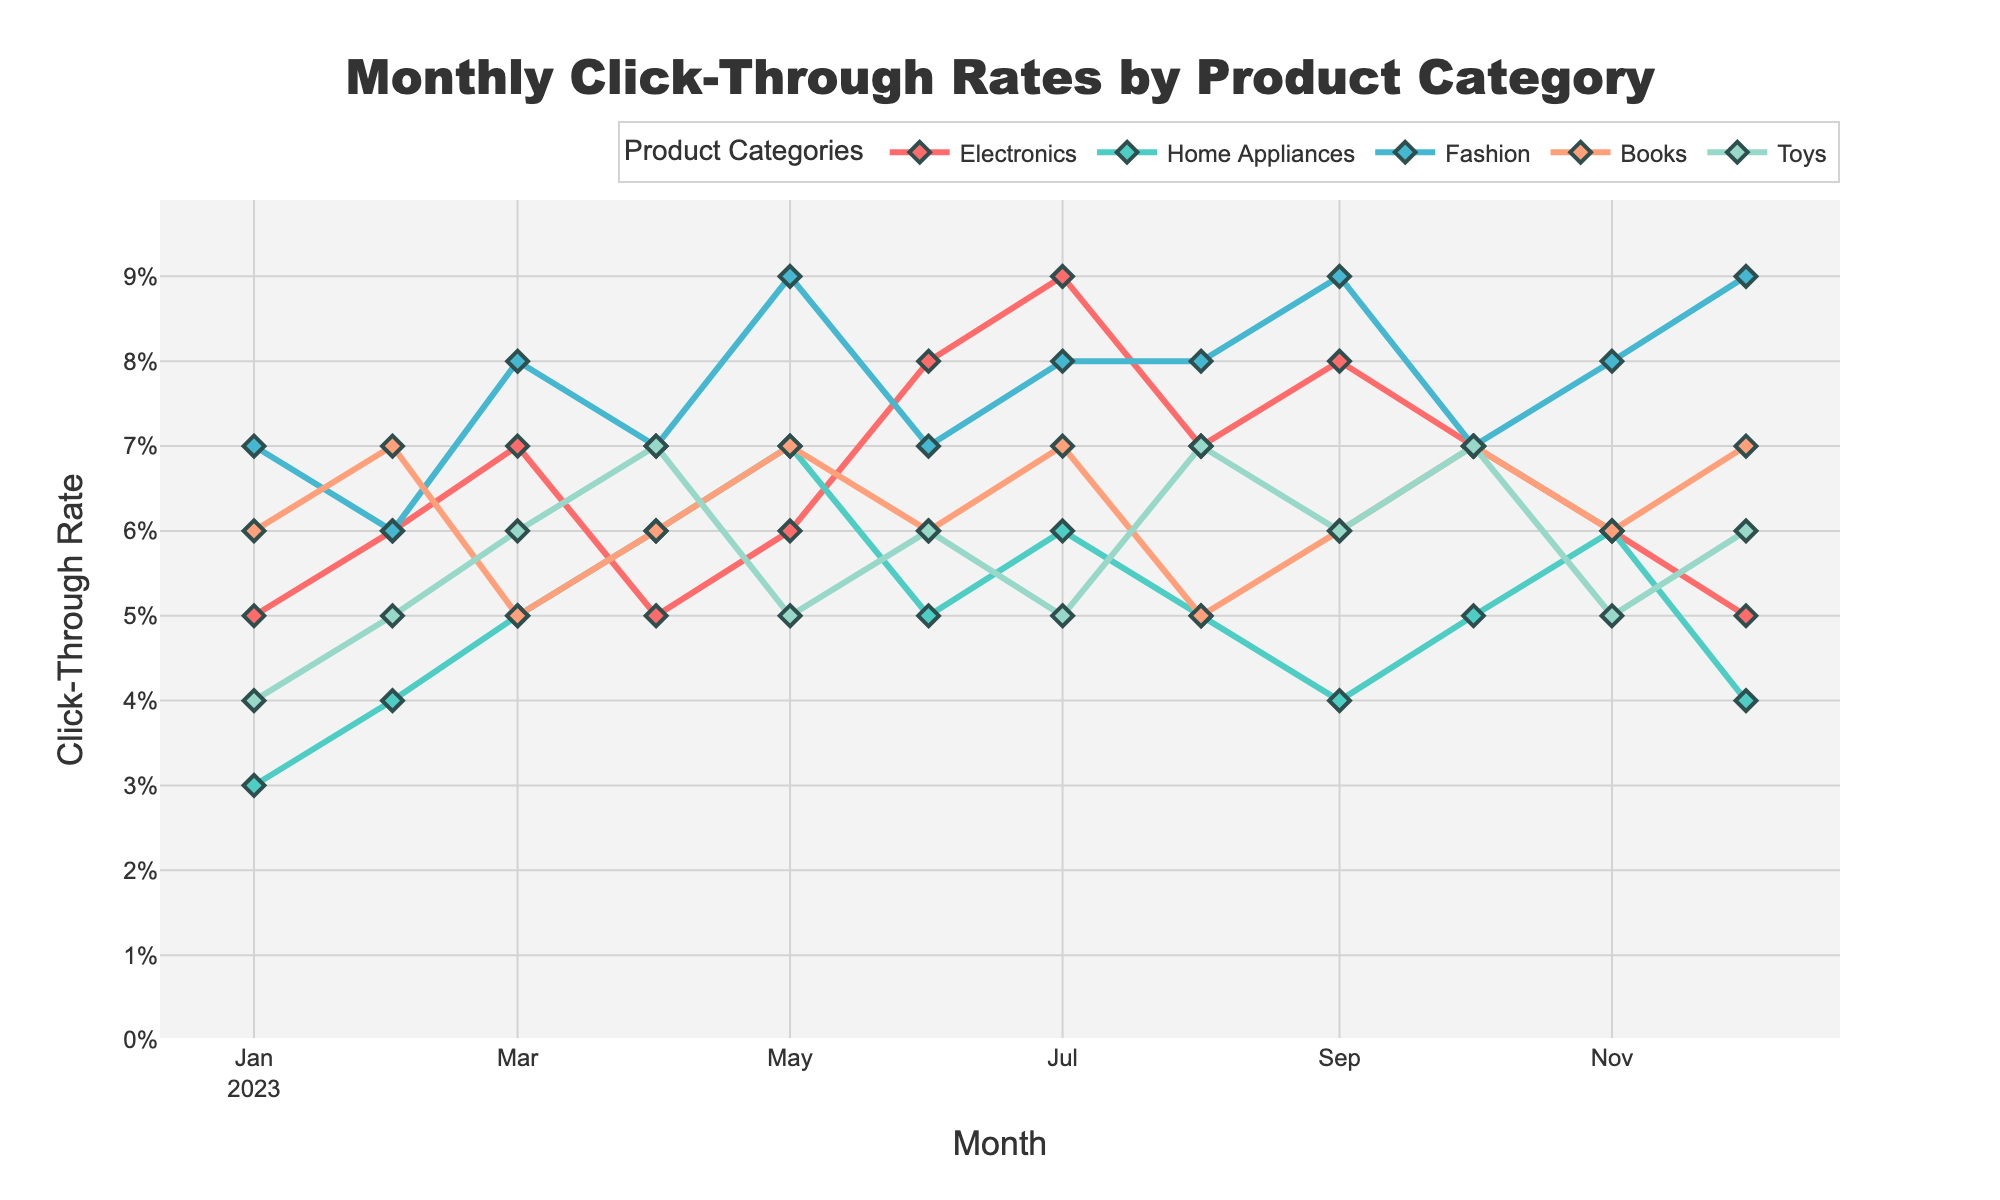What is the title of the figure? The title is usually placed at the top of the chart and provides a brief explanation of what the chart is about. In this figure, the title is "Monthly Click-Through Rates by Product Category".
Answer: Monthly Click-Through Rates by Product Category What is the click-through rate for Electronics in January 2023? To find the click-through rate for Electronics in January 2023, locate the data point on the Electronics line (denoted by color) at January 2023 on the x-axis.
Answer: 0.05 Which product category had the highest click-through rate in May 2023? Look at the data points for all categories in May 2023 to see which one has the highest value.
Answer: Fashion Between which months does the click-through rate for Toys show the largest increase? Observe the Toys line and identify the interval between two consecutive months where the increase is greatest. The increase is greatest between January 2023 and February 2023.
Answer: January to February 2023 What is the average click-through rate for Home Appliances over the year 2023? Sum the click-through rates for Home Appliances for each month in 2023, then divide by the number of months (12). The calculation is (0.03 + 0.04 + 0.05 + 0.06 + 0.07 + 0.05 + 0.06 + 0.05 + 0.04 + 0.05 + 0.06 + 0.04) / 12 = 0.05.
Answer: 0.05 Which product category had the most stable click-through rates throughout the year? Look at the consistency of the click-through rates across all months for each category. The line for Books shows the least fluctuation throughout the year.
Answer: Books In which month did Fashion see the maximum click-through rate? Identify the peak point on the Fashion line and see which month it corresponds to.
Answer: May 2023 By how much did the click-through rate for Electronics increase from January 2023 to July 2023? Find the click-through rate for Electronics in both months and then calculate the difference: 0.09 - 0.05 = 0.04.
Answer: 0.04 How did the click-through rate for Books change from February 2023 to March 2023? Compare the click-through rates for Books in both months to determine whether it increased, decreased, or stayed the same: 0.07 (February) to 0.05 (March).
Answer: Decreased Which months show an identical click-through rate for at least two product categories? Compare the click-through rates of all categories for each month to find months with identical rates. For example, in July 2023, both Home Appliances and Fashion have a click-through rate of 0.08.
Answer: July 2023 